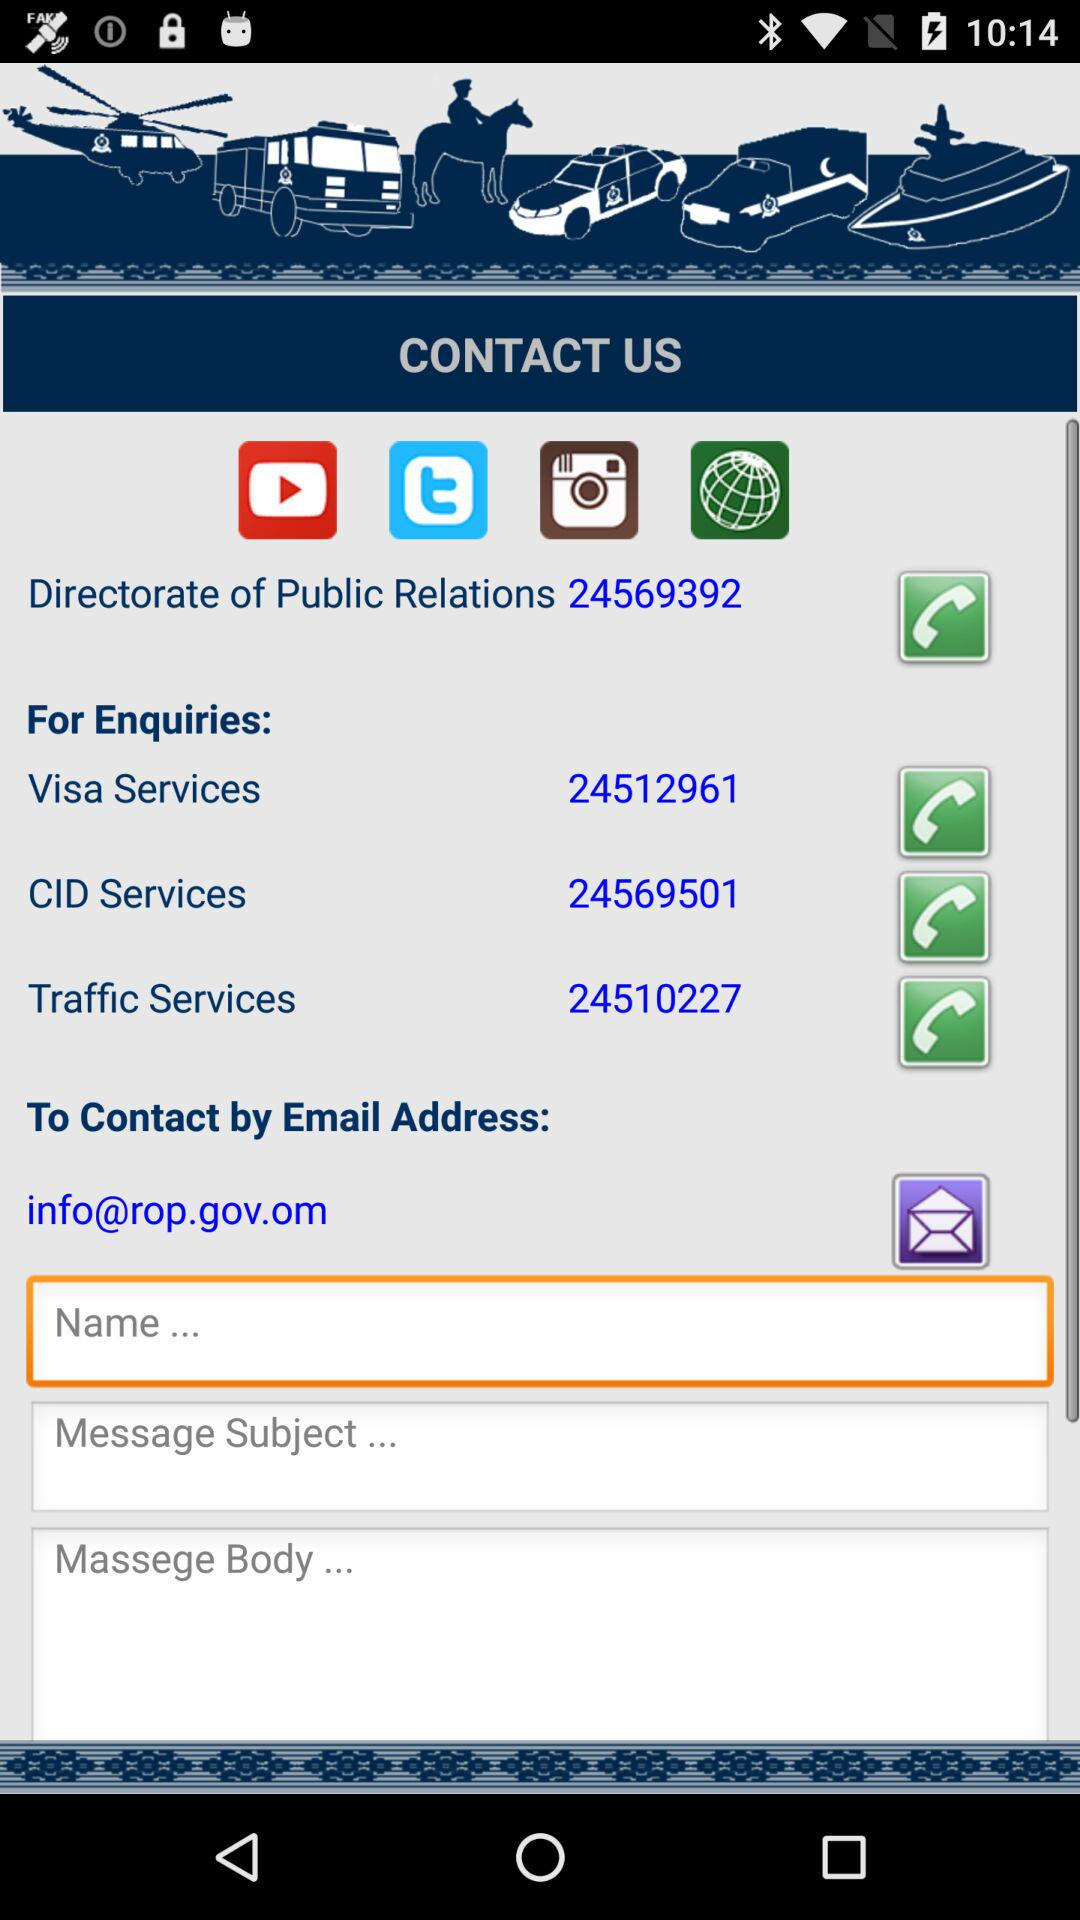What's the email address? The email address is info@rov.gov.om. 